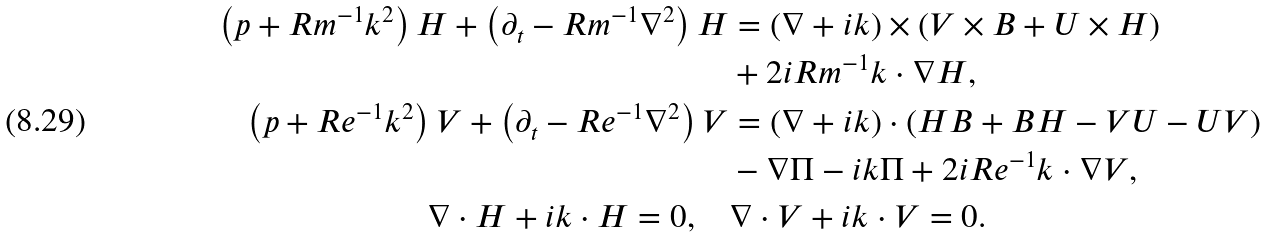Convert formula to latex. <formula><loc_0><loc_0><loc_500><loc_500>\left ( p + R m ^ { - 1 } k ^ { 2 } \right ) H + \left ( \partial _ { t } - R m ^ { - 1 } \nabla ^ { 2 } \right ) H & = \left ( \nabla + i k \right ) \times \left ( V \times B + U \times H \right ) \\ & + 2 i R m ^ { - 1 } k \cdot \nabla H , \\ \left ( p + R e ^ { - 1 } k ^ { 2 } \right ) V + \left ( \partial _ { t } - R e ^ { - 1 } \nabla ^ { 2 } \right ) V & = \left ( \nabla + i k \right ) \cdot \left ( H B + B H - V U - U V \right ) \\ & - \nabla \Pi - i k \Pi + 2 i R e ^ { - 1 } k \cdot \nabla V , \\ \nabla \cdot H + i k \cdot H = 0 , \quad & \nabla \cdot V + i k \cdot V = 0 .</formula> 